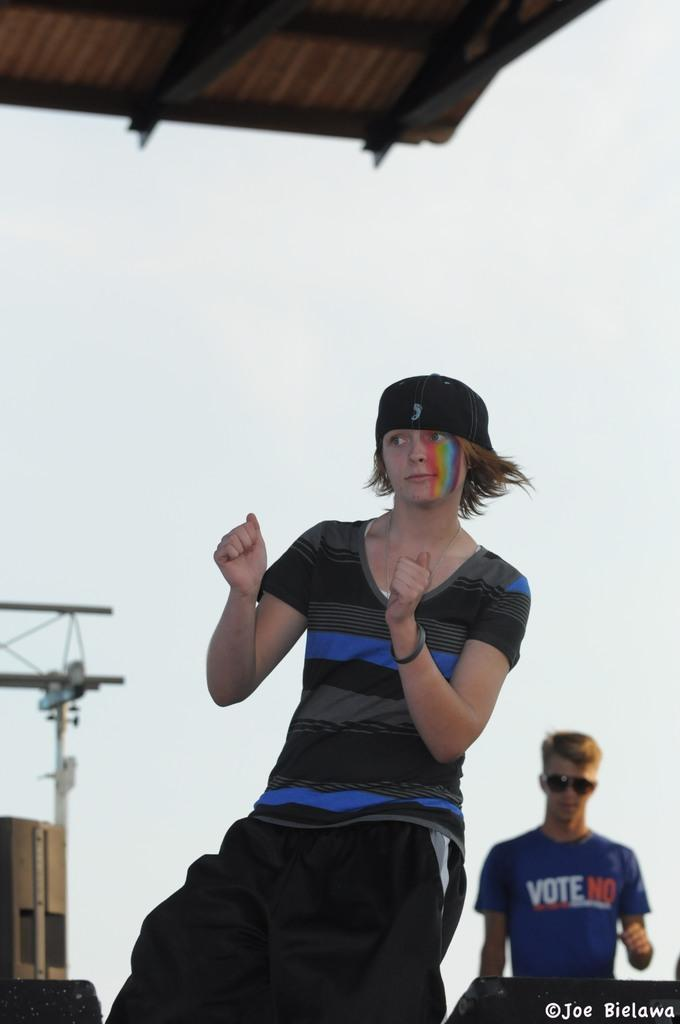<image>
Render a clear and concise summary of the photo. two people wearing black or blue shirts with VOTE NO written on one 